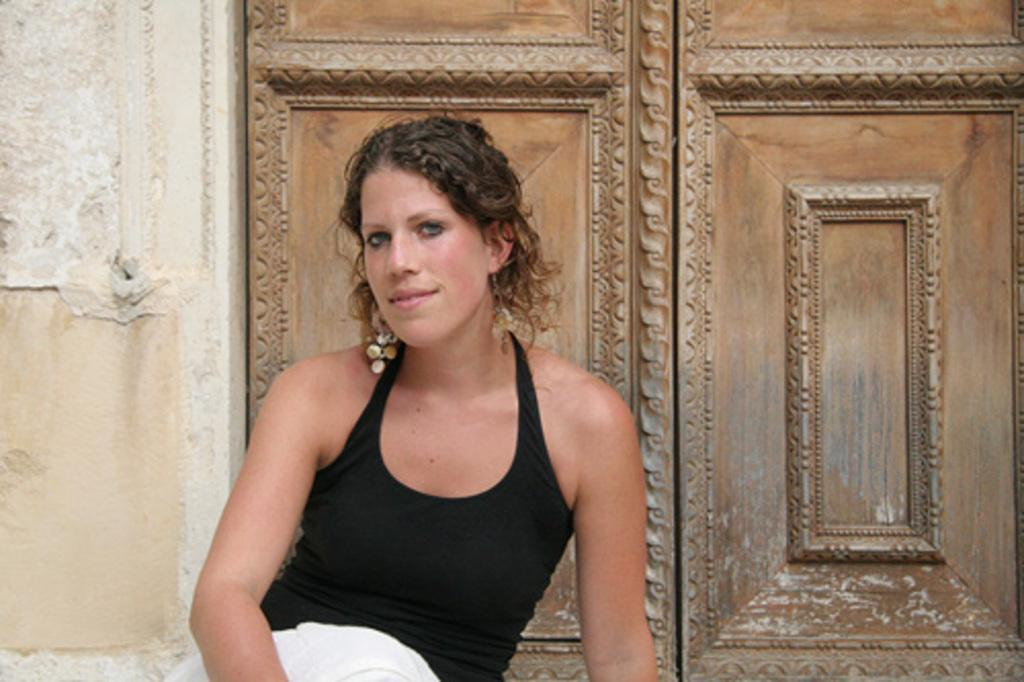Who is present in the image? There is a woman in the image. What is the woman doing in the image? The woman is sitting. What is the woman's facial expression in the image? The woman is smiling. What color is the top the woman is wearing in the image? The woman is wearing a black top. What can be seen in the background of the image? There is a wall and wooden doors in the background of the image. What type of crayon is the woman holding in the image? There is no crayon present in the image. How does the woman use the celery in the image? There is no celery present in the image. 